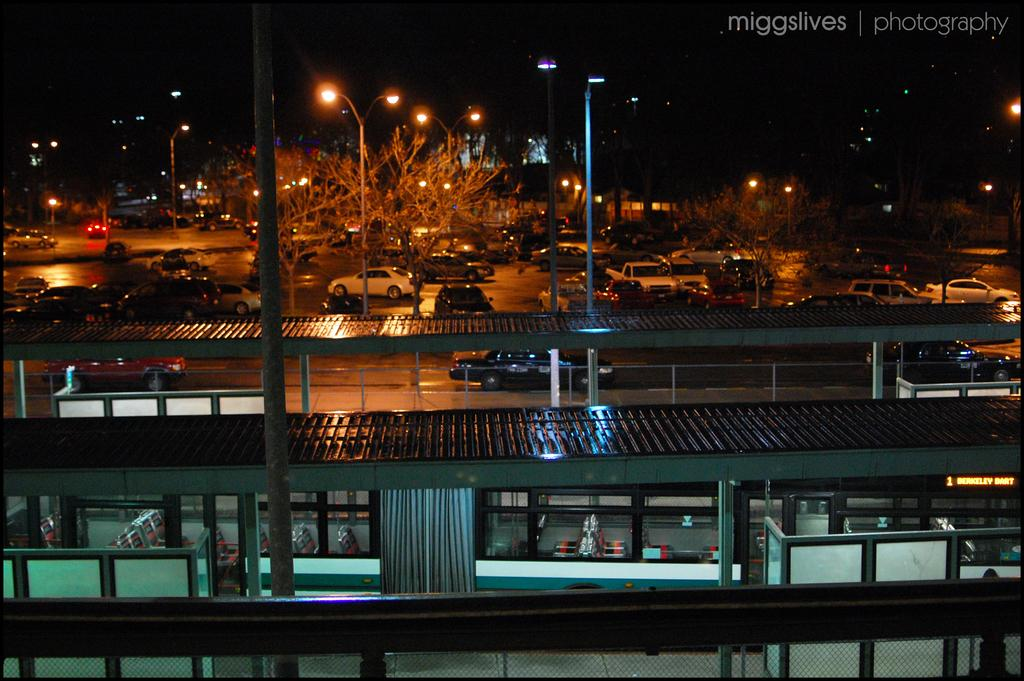What is the main subject of the image? The main subject of the image is a train. What else can be seen in the image besides the train? There is a platform, a fence, trees, poles, lights, vehicles on the road, and a dark background visible in the image. Where can the waste be found in the image? There is no mention of waste in the image, so it cannot be found. How many ducks are visible on the train in the image? There are no ducks present in the image, so there cannot be any ducks on the train. 